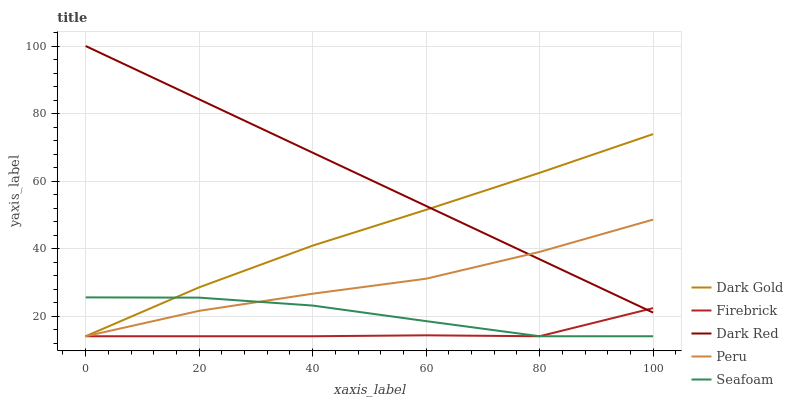Does Firebrick have the minimum area under the curve?
Answer yes or no. Yes. Does Dark Red have the maximum area under the curve?
Answer yes or no. Yes. Does Seafoam have the minimum area under the curve?
Answer yes or no. No. Does Seafoam have the maximum area under the curve?
Answer yes or no. No. Is Dark Red the smoothest?
Answer yes or no. Yes. Is Firebrick the roughest?
Answer yes or no. Yes. Is Seafoam the smoothest?
Answer yes or no. No. Is Seafoam the roughest?
Answer yes or no. No. Does Firebrick have the lowest value?
Answer yes or no. Yes. Does Dark Red have the highest value?
Answer yes or no. Yes. Does Seafoam have the highest value?
Answer yes or no. No. Is Seafoam less than Dark Red?
Answer yes or no. Yes. Is Dark Red greater than Seafoam?
Answer yes or no. Yes. Does Seafoam intersect Peru?
Answer yes or no. Yes. Is Seafoam less than Peru?
Answer yes or no. No. Is Seafoam greater than Peru?
Answer yes or no. No. Does Seafoam intersect Dark Red?
Answer yes or no. No. 